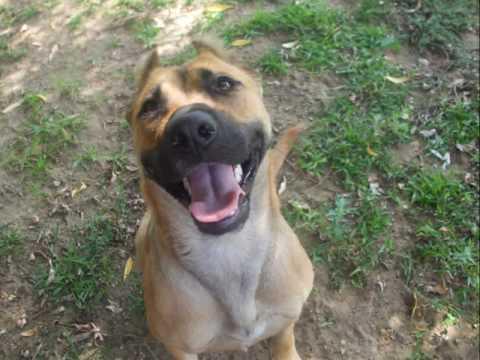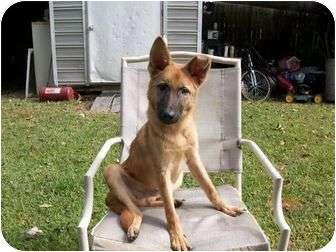The first image is the image on the left, the second image is the image on the right. Given the left and right images, does the statement "the puppy is sitting on a wooden platform" hold true? Answer yes or no. No. The first image is the image on the left, the second image is the image on the right. For the images shown, is this caption "A dog is carrying something in its mouth" true? Answer yes or no. No. 